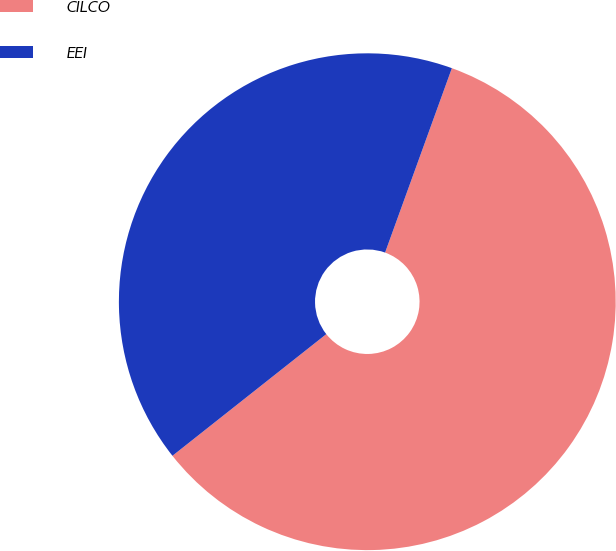Convert chart. <chart><loc_0><loc_0><loc_500><loc_500><pie_chart><fcel>CILCO<fcel>EEI<nl><fcel>58.82%<fcel>41.18%<nl></chart> 